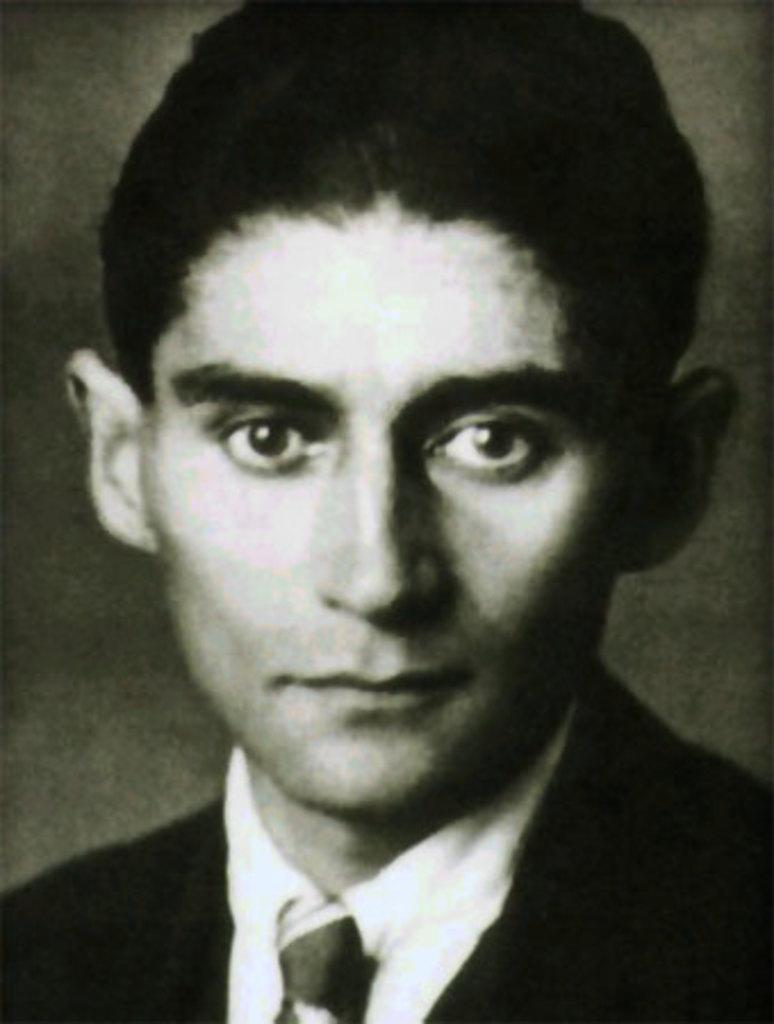What is the main subject of the image? There is a man's face in the image. What type of clothing is the man wearing? The man is wearing a shirt, a tie, and a coat. What is the color scheme of the image? The image is black and white in color. Reasoning: Let's think step by step by step in order to produce the conversation. We start by identifying the main subject of the image, which is the man's face. Then, we describe the clothing the man is wearing, including his shirt, tie, and coat. Finally, we mention the color scheme of the image, which is black and white. Each question is designed to elicit a specific detail about the image that is known from the provided facts. Absurd Question/Answer: What type of operation is being performed in the image? There is no operation being performed in the image; it features a man's face with clothing details. Can you tell me how many books are visible in the library in the image? There is no library or books present in the image; it features a man's face with clothing details. What type of operation is being performed in the image? There is no operation being performed in the image; it features a man's face with clothing details. Can you tell me how many books are visible in the library in the image? There is no library or books present in the image; it features a man's face with clothing details. 